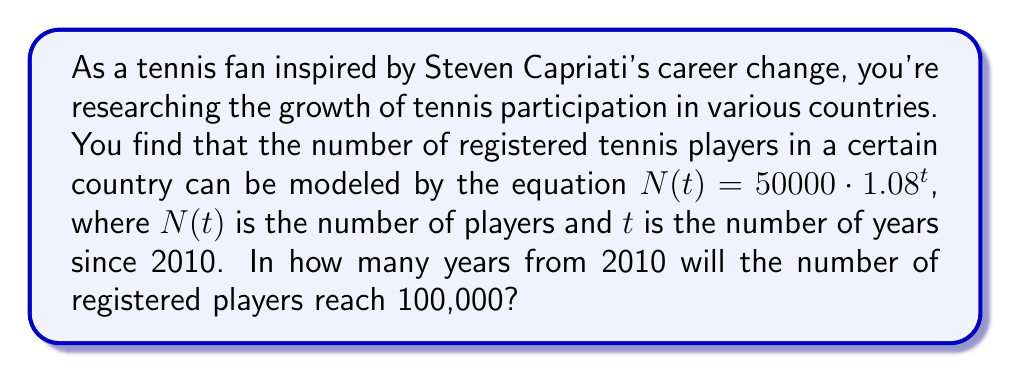Provide a solution to this math problem. To solve this problem, we need to use logarithms to isolate the variable $t$. Let's approach this step-by-step:

1) We start with the equation: $N(t) = 50000 \cdot 1.08^t$

2) We want to find when $N(t) = 100000$, so we set up the equation:
   $100000 = 50000 \cdot 1.08^t$

3) Divide both sides by 50000:
   $2 = 1.08^t$

4) Now we need to take the logarithm of both sides. We can use any base, but the natural log (ln) is often convenient:
   $\ln(2) = \ln(1.08^t)$

5) Using the logarithm property $\ln(a^b) = b\ln(a)$, we get:
   $\ln(2) = t \cdot \ln(1.08)$

6) Now we can isolate $t$:
   $t = \frac{\ln(2)}{\ln(1.08)}$

7) Using a calculator or computer:
   $t \approx 9.006$

8) Since we're dealing with whole years, we need to round up to the next integer.
Answer: The number of registered players will reach 100,000 in 10 years from 2010. 